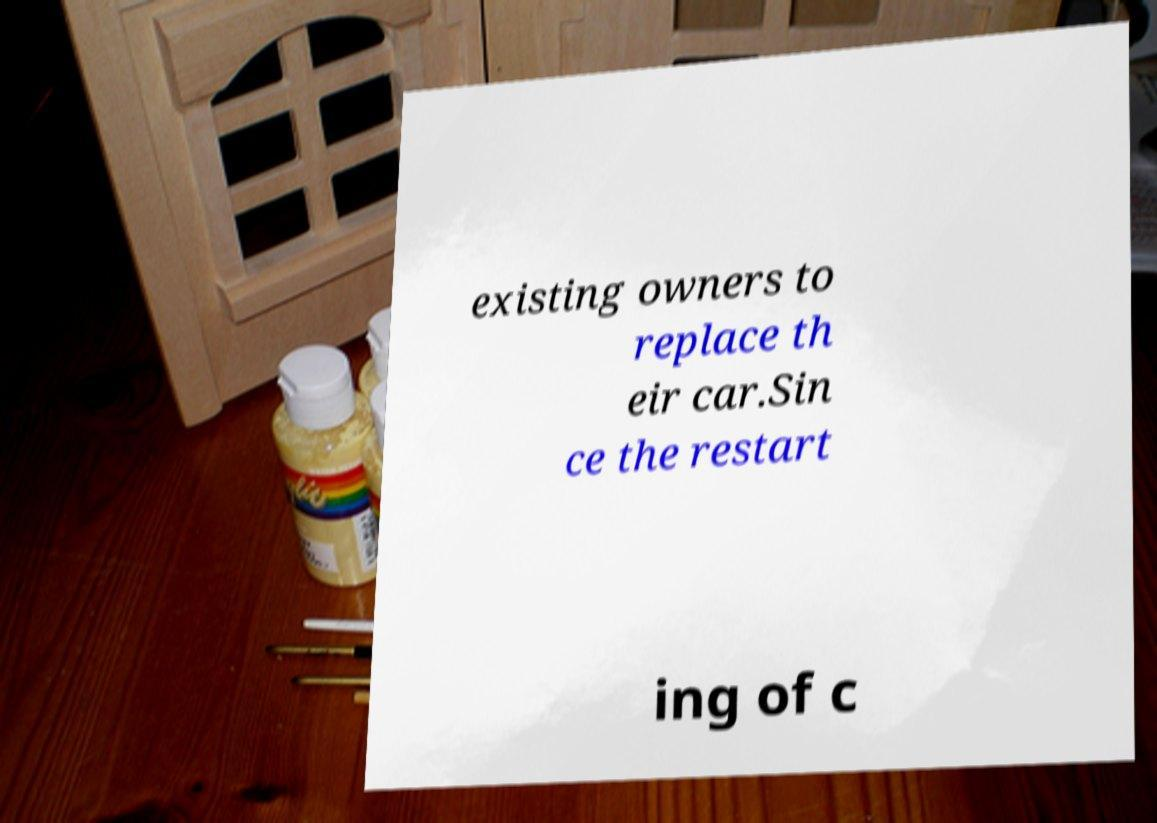Can you accurately transcribe the text from the provided image for me? existing owners to replace th eir car.Sin ce the restart ing of c 